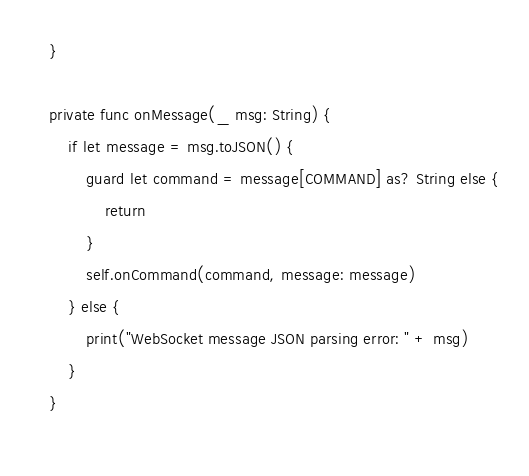<code> <loc_0><loc_0><loc_500><loc_500><_Swift_>    }
    
    private func onMessage(_ msg: String) {
        if let message = msg.toJSON() {
            guard let command = message[COMMAND] as? String else {
                return
            }
            self.onCommand(command, message: message)
        } else {
            print("WebSocket message JSON parsing error: " + msg)
        }
    }
    </code> 